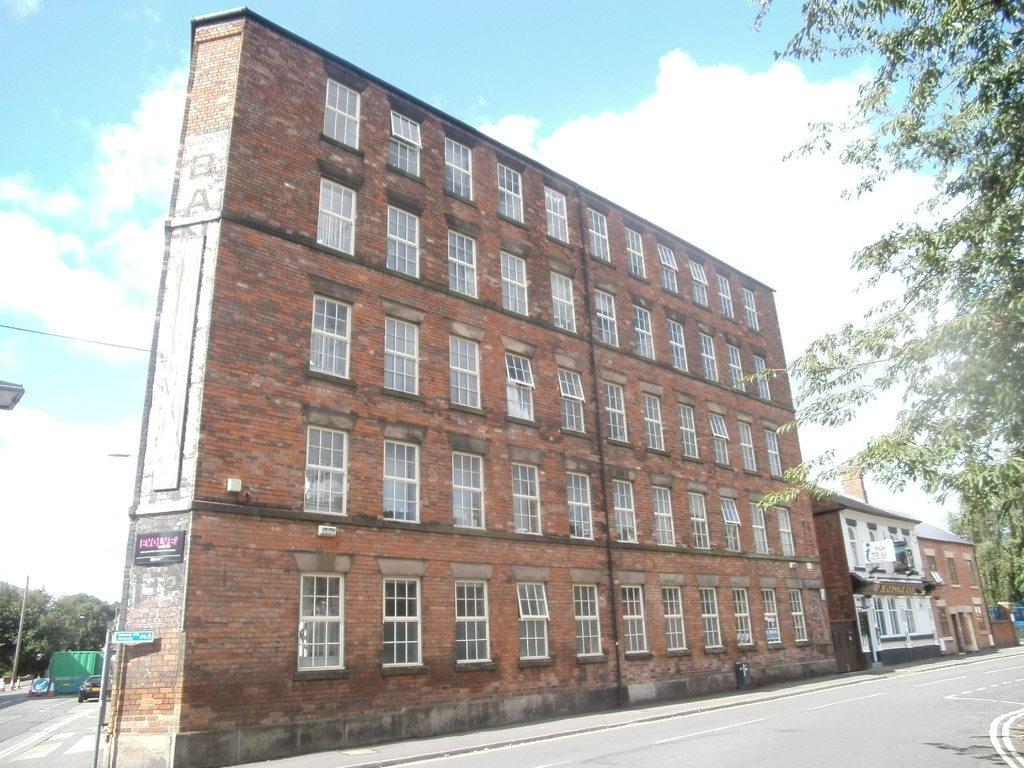In one or two sentences, can you explain what this image depicts? In this picture we can see buildings with windows, trees and a car on the road and in the background we can see the sky with clouds. 